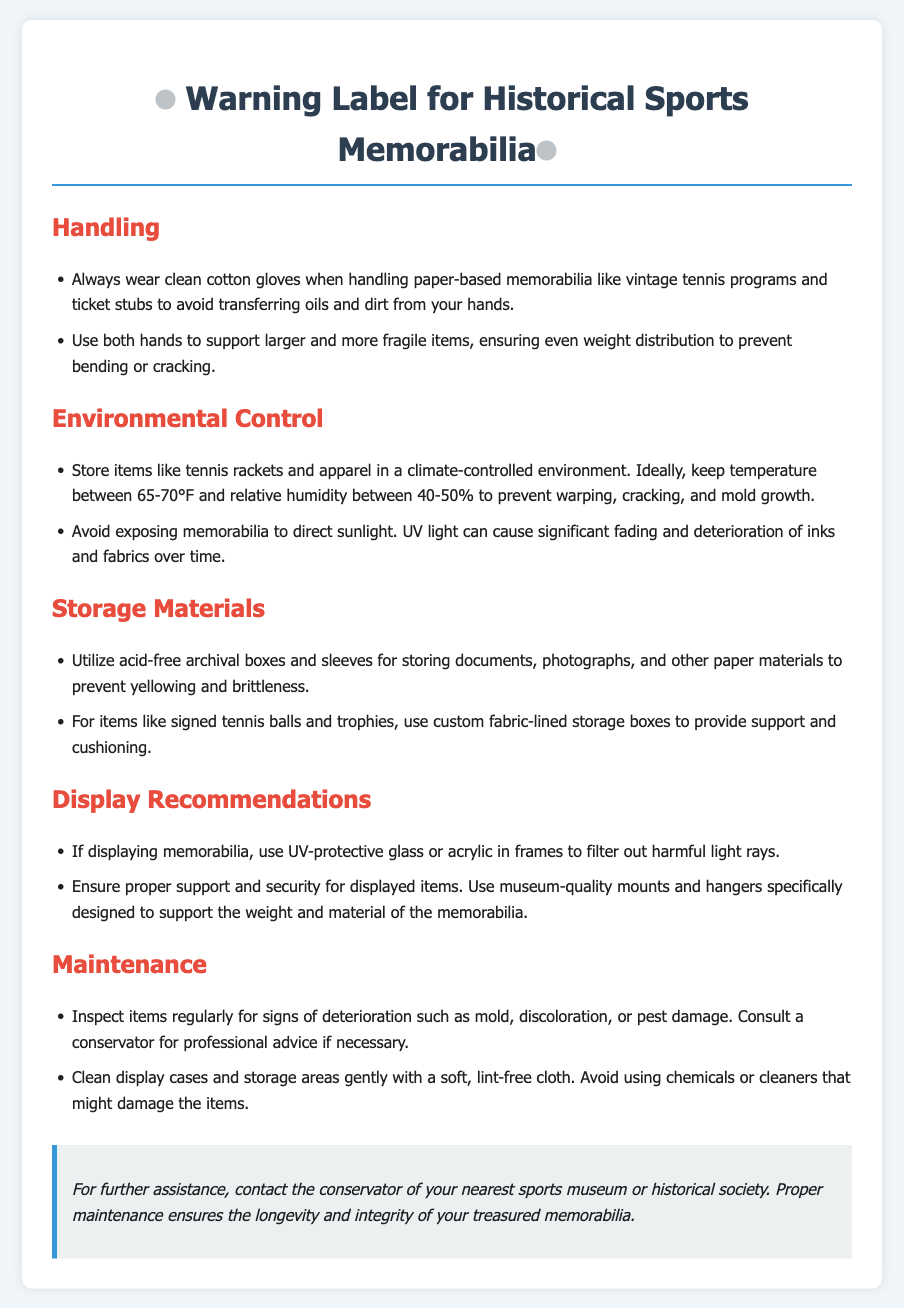What should you always wear when handling paper-based memorabilia? The document states that you should always wear clean cotton gloves when handling paper-based memorabilia.
Answer: Clean cotton gloves What is the ideal temperature range for storing items? The document specifies that the ideal temperature range is between 65-70°F for storing items.
Answer: 65-70°F What type of storage boxes should be used for documents? The warning label advises using acid-free archival boxes for storing documents.
Answer: Acid-free archival boxes How often should items be inspected for signs of deterioration? The document suggests inspecting items regularly for signs of deterioration.
Answer: Regularly What type of glass should be used for displaying memorabilia? The document recommends using UV-protective glass or acrylic for displaying memorabilia.
Answer: UV-protective glass or acrylic Why should memorabilia not be exposed to direct sunlight? The document explains that UV light can cause significant fading and deterioration of inks and fabrics over time.
Answer: Fading and deterioration What should be avoided when cleaning display cases? The warning label advises avoiding chemicals or cleaners that might damage the items when cleaning display cases.
Answer: Chemicals or cleaners What is recommended for supporting larger and more fragile items? The document states that you should use both hands to support larger and more fragile items for even weight distribution.
Answer: Both hands 